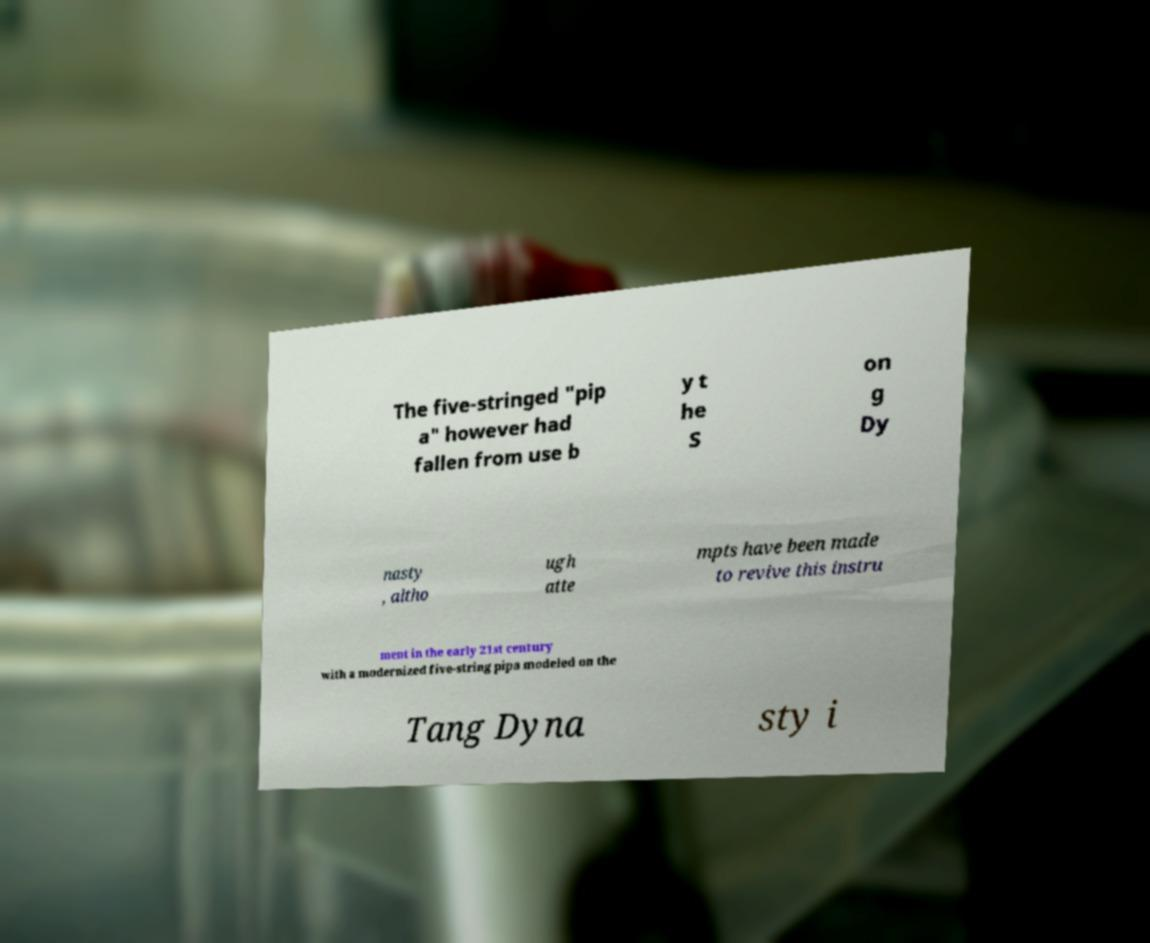I need the written content from this picture converted into text. Can you do that? The five-stringed "pip a" however had fallen from use b y t he S on g Dy nasty , altho ugh atte mpts have been made to revive this instru ment in the early 21st century with a modernized five-string pipa modeled on the Tang Dyna sty i 